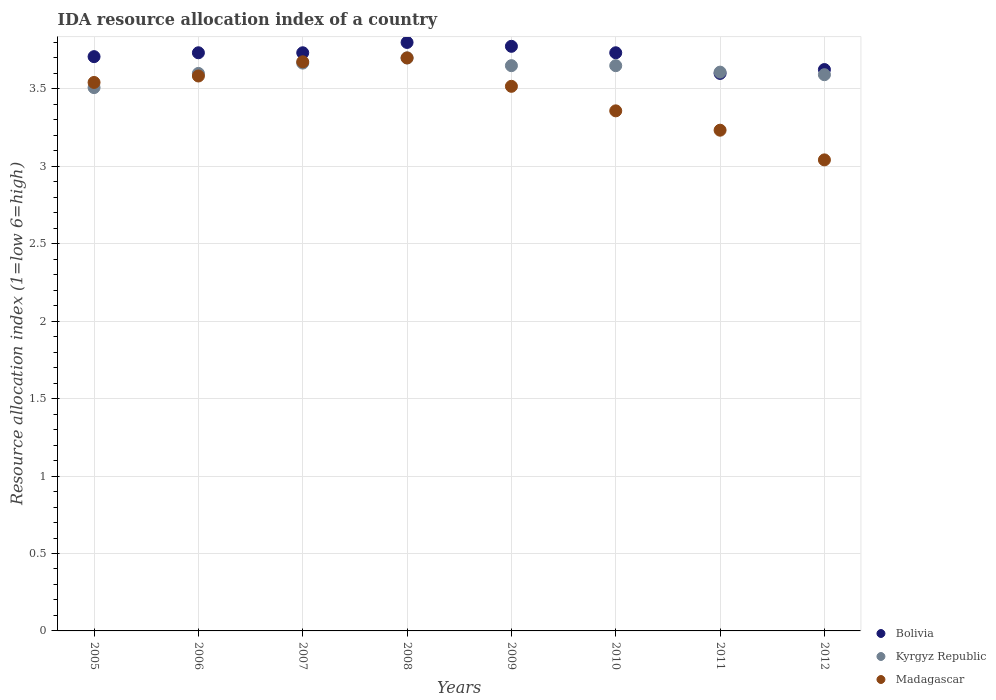How many different coloured dotlines are there?
Your response must be concise. 3. What is the IDA resource allocation index in Bolivia in 2010?
Your response must be concise. 3.73. Across all years, what is the maximum IDA resource allocation index in Kyrgyz Republic?
Offer a terse response. 3.7. Across all years, what is the minimum IDA resource allocation index in Kyrgyz Republic?
Your answer should be compact. 3.51. In which year was the IDA resource allocation index in Madagascar maximum?
Give a very brief answer. 2008. What is the total IDA resource allocation index in Bolivia in the graph?
Provide a short and direct response. 29.71. What is the difference between the IDA resource allocation index in Bolivia in 2005 and that in 2007?
Give a very brief answer. -0.02. What is the difference between the IDA resource allocation index in Madagascar in 2011 and the IDA resource allocation index in Bolivia in 2005?
Offer a very short reply. -0.47. What is the average IDA resource allocation index in Madagascar per year?
Keep it short and to the point. 3.46. In the year 2008, what is the difference between the IDA resource allocation index in Kyrgyz Republic and IDA resource allocation index in Bolivia?
Keep it short and to the point. -0.1. What is the ratio of the IDA resource allocation index in Kyrgyz Republic in 2005 to that in 2011?
Make the answer very short. 0.97. What is the difference between the highest and the second highest IDA resource allocation index in Kyrgyz Republic?
Provide a short and direct response. 0.03. What is the difference between the highest and the lowest IDA resource allocation index in Kyrgyz Republic?
Offer a terse response. 0.19. Is the sum of the IDA resource allocation index in Madagascar in 2005 and 2011 greater than the maximum IDA resource allocation index in Bolivia across all years?
Give a very brief answer. Yes. Does the IDA resource allocation index in Bolivia monotonically increase over the years?
Keep it short and to the point. No. Is the IDA resource allocation index in Madagascar strictly less than the IDA resource allocation index in Kyrgyz Republic over the years?
Your answer should be compact. No. Does the graph contain any zero values?
Your answer should be compact. No. What is the title of the graph?
Keep it short and to the point. IDA resource allocation index of a country. Does "Uruguay" appear as one of the legend labels in the graph?
Your response must be concise. No. What is the label or title of the Y-axis?
Your answer should be very brief. Resource allocation index (1=low 6=high). What is the Resource allocation index (1=low 6=high) in Bolivia in 2005?
Offer a terse response. 3.71. What is the Resource allocation index (1=low 6=high) in Kyrgyz Republic in 2005?
Your response must be concise. 3.51. What is the Resource allocation index (1=low 6=high) of Madagascar in 2005?
Ensure brevity in your answer.  3.54. What is the Resource allocation index (1=low 6=high) of Bolivia in 2006?
Make the answer very short. 3.73. What is the Resource allocation index (1=low 6=high) in Kyrgyz Republic in 2006?
Keep it short and to the point. 3.6. What is the Resource allocation index (1=low 6=high) of Madagascar in 2006?
Make the answer very short. 3.58. What is the Resource allocation index (1=low 6=high) of Bolivia in 2007?
Give a very brief answer. 3.73. What is the Resource allocation index (1=low 6=high) in Kyrgyz Republic in 2007?
Ensure brevity in your answer.  3.67. What is the Resource allocation index (1=low 6=high) of Madagascar in 2007?
Offer a terse response. 3.67. What is the Resource allocation index (1=low 6=high) in Bolivia in 2008?
Offer a very short reply. 3.8. What is the Resource allocation index (1=low 6=high) of Madagascar in 2008?
Offer a very short reply. 3.7. What is the Resource allocation index (1=low 6=high) in Bolivia in 2009?
Offer a very short reply. 3.77. What is the Resource allocation index (1=low 6=high) in Kyrgyz Republic in 2009?
Make the answer very short. 3.65. What is the Resource allocation index (1=low 6=high) in Madagascar in 2009?
Make the answer very short. 3.52. What is the Resource allocation index (1=low 6=high) in Bolivia in 2010?
Your answer should be very brief. 3.73. What is the Resource allocation index (1=low 6=high) of Kyrgyz Republic in 2010?
Your answer should be compact. 3.65. What is the Resource allocation index (1=low 6=high) in Madagascar in 2010?
Make the answer very short. 3.36. What is the Resource allocation index (1=low 6=high) in Kyrgyz Republic in 2011?
Offer a terse response. 3.61. What is the Resource allocation index (1=low 6=high) of Madagascar in 2011?
Provide a succinct answer. 3.23. What is the Resource allocation index (1=low 6=high) in Bolivia in 2012?
Your response must be concise. 3.62. What is the Resource allocation index (1=low 6=high) of Kyrgyz Republic in 2012?
Provide a succinct answer. 3.59. What is the Resource allocation index (1=low 6=high) of Madagascar in 2012?
Offer a terse response. 3.04. Across all years, what is the maximum Resource allocation index (1=low 6=high) in Bolivia?
Your answer should be very brief. 3.8. Across all years, what is the maximum Resource allocation index (1=low 6=high) in Kyrgyz Republic?
Make the answer very short. 3.7. Across all years, what is the minimum Resource allocation index (1=low 6=high) in Kyrgyz Republic?
Provide a succinct answer. 3.51. Across all years, what is the minimum Resource allocation index (1=low 6=high) of Madagascar?
Offer a very short reply. 3.04. What is the total Resource allocation index (1=low 6=high) in Bolivia in the graph?
Make the answer very short. 29.71. What is the total Resource allocation index (1=low 6=high) of Kyrgyz Republic in the graph?
Keep it short and to the point. 28.98. What is the total Resource allocation index (1=low 6=high) of Madagascar in the graph?
Make the answer very short. 27.65. What is the difference between the Resource allocation index (1=low 6=high) of Bolivia in 2005 and that in 2006?
Give a very brief answer. -0.03. What is the difference between the Resource allocation index (1=low 6=high) of Kyrgyz Republic in 2005 and that in 2006?
Provide a succinct answer. -0.09. What is the difference between the Resource allocation index (1=low 6=high) of Madagascar in 2005 and that in 2006?
Provide a short and direct response. -0.04. What is the difference between the Resource allocation index (1=low 6=high) of Bolivia in 2005 and that in 2007?
Give a very brief answer. -0.03. What is the difference between the Resource allocation index (1=low 6=high) in Kyrgyz Republic in 2005 and that in 2007?
Provide a short and direct response. -0.16. What is the difference between the Resource allocation index (1=low 6=high) in Madagascar in 2005 and that in 2007?
Offer a very short reply. -0.13. What is the difference between the Resource allocation index (1=low 6=high) in Bolivia in 2005 and that in 2008?
Make the answer very short. -0.09. What is the difference between the Resource allocation index (1=low 6=high) of Kyrgyz Republic in 2005 and that in 2008?
Your answer should be very brief. -0.19. What is the difference between the Resource allocation index (1=low 6=high) of Madagascar in 2005 and that in 2008?
Your response must be concise. -0.16. What is the difference between the Resource allocation index (1=low 6=high) of Bolivia in 2005 and that in 2009?
Provide a short and direct response. -0.07. What is the difference between the Resource allocation index (1=low 6=high) of Kyrgyz Republic in 2005 and that in 2009?
Your response must be concise. -0.14. What is the difference between the Resource allocation index (1=low 6=high) of Madagascar in 2005 and that in 2009?
Offer a terse response. 0.03. What is the difference between the Resource allocation index (1=low 6=high) in Bolivia in 2005 and that in 2010?
Offer a very short reply. -0.03. What is the difference between the Resource allocation index (1=low 6=high) of Kyrgyz Republic in 2005 and that in 2010?
Provide a succinct answer. -0.14. What is the difference between the Resource allocation index (1=low 6=high) in Madagascar in 2005 and that in 2010?
Give a very brief answer. 0.18. What is the difference between the Resource allocation index (1=low 6=high) in Bolivia in 2005 and that in 2011?
Provide a succinct answer. 0.11. What is the difference between the Resource allocation index (1=low 6=high) in Madagascar in 2005 and that in 2011?
Your answer should be very brief. 0.31. What is the difference between the Resource allocation index (1=low 6=high) of Bolivia in 2005 and that in 2012?
Offer a terse response. 0.08. What is the difference between the Resource allocation index (1=low 6=high) in Kyrgyz Republic in 2005 and that in 2012?
Your answer should be very brief. -0.08. What is the difference between the Resource allocation index (1=low 6=high) of Madagascar in 2005 and that in 2012?
Offer a terse response. 0.5. What is the difference between the Resource allocation index (1=low 6=high) in Kyrgyz Republic in 2006 and that in 2007?
Offer a very short reply. -0.07. What is the difference between the Resource allocation index (1=low 6=high) of Madagascar in 2006 and that in 2007?
Ensure brevity in your answer.  -0.09. What is the difference between the Resource allocation index (1=low 6=high) of Bolivia in 2006 and that in 2008?
Your response must be concise. -0.07. What is the difference between the Resource allocation index (1=low 6=high) in Kyrgyz Republic in 2006 and that in 2008?
Your response must be concise. -0.1. What is the difference between the Resource allocation index (1=low 6=high) in Madagascar in 2006 and that in 2008?
Provide a succinct answer. -0.12. What is the difference between the Resource allocation index (1=low 6=high) in Bolivia in 2006 and that in 2009?
Ensure brevity in your answer.  -0.04. What is the difference between the Resource allocation index (1=low 6=high) in Kyrgyz Republic in 2006 and that in 2009?
Offer a terse response. -0.05. What is the difference between the Resource allocation index (1=low 6=high) in Madagascar in 2006 and that in 2009?
Make the answer very short. 0.07. What is the difference between the Resource allocation index (1=low 6=high) of Madagascar in 2006 and that in 2010?
Offer a terse response. 0.23. What is the difference between the Resource allocation index (1=low 6=high) of Bolivia in 2006 and that in 2011?
Your answer should be compact. 0.13. What is the difference between the Resource allocation index (1=low 6=high) in Kyrgyz Republic in 2006 and that in 2011?
Ensure brevity in your answer.  -0.01. What is the difference between the Resource allocation index (1=low 6=high) in Bolivia in 2006 and that in 2012?
Keep it short and to the point. 0.11. What is the difference between the Resource allocation index (1=low 6=high) of Kyrgyz Republic in 2006 and that in 2012?
Make the answer very short. 0.01. What is the difference between the Resource allocation index (1=low 6=high) of Madagascar in 2006 and that in 2012?
Ensure brevity in your answer.  0.54. What is the difference between the Resource allocation index (1=low 6=high) of Bolivia in 2007 and that in 2008?
Make the answer very short. -0.07. What is the difference between the Resource allocation index (1=low 6=high) of Kyrgyz Republic in 2007 and that in 2008?
Your answer should be very brief. -0.03. What is the difference between the Resource allocation index (1=low 6=high) of Madagascar in 2007 and that in 2008?
Make the answer very short. -0.03. What is the difference between the Resource allocation index (1=low 6=high) in Bolivia in 2007 and that in 2009?
Your answer should be very brief. -0.04. What is the difference between the Resource allocation index (1=low 6=high) of Kyrgyz Republic in 2007 and that in 2009?
Make the answer very short. 0.02. What is the difference between the Resource allocation index (1=low 6=high) in Madagascar in 2007 and that in 2009?
Give a very brief answer. 0.16. What is the difference between the Resource allocation index (1=low 6=high) of Bolivia in 2007 and that in 2010?
Ensure brevity in your answer.  0. What is the difference between the Resource allocation index (1=low 6=high) in Kyrgyz Republic in 2007 and that in 2010?
Ensure brevity in your answer.  0.02. What is the difference between the Resource allocation index (1=low 6=high) in Madagascar in 2007 and that in 2010?
Your response must be concise. 0.32. What is the difference between the Resource allocation index (1=low 6=high) in Bolivia in 2007 and that in 2011?
Ensure brevity in your answer.  0.13. What is the difference between the Resource allocation index (1=low 6=high) in Kyrgyz Republic in 2007 and that in 2011?
Provide a short and direct response. 0.06. What is the difference between the Resource allocation index (1=low 6=high) in Madagascar in 2007 and that in 2011?
Your answer should be compact. 0.44. What is the difference between the Resource allocation index (1=low 6=high) in Bolivia in 2007 and that in 2012?
Make the answer very short. 0.11. What is the difference between the Resource allocation index (1=low 6=high) of Kyrgyz Republic in 2007 and that in 2012?
Provide a short and direct response. 0.07. What is the difference between the Resource allocation index (1=low 6=high) of Madagascar in 2007 and that in 2012?
Provide a short and direct response. 0.63. What is the difference between the Resource allocation index (1=low 6=high) in Bolivia in 2008 and that in 2009?
Make the answer very short. 0.03. What is the difference between the Resource allocation index (1=low 6=high) of Kyrgyz Republic in 2008 and that in 2009?
Ensure brevity in your answer.  0.05. What is the difference between the Resource allocation index (1=low 6=high) in Madagascar in 2008 and that in 2009?
Your response must be concise. 0.18. What is the difference between the Resource allocation index (1=low 6=high) of Bolivia in 2008 and that in 2010?
Offer a very short reply. 0.07. What is the difference between the Resource allocation index (1=low 6=high) in Kyrgyz Republic in 2008 and that in 2010?
Make the answer very short. 0.05. What is the difference between the Resource allocation index (1=low 6=high) of Madagascar in 2008 and that in 2010?
Offer a terse response. 0.34. What is the difference between the Resource allocation index (1=low 6=high) in Kyrgyz Republic in 2008 and that in 2011?
Make the answer very short. 0.09. What is the difference between the Resource allocation index (1=low 6=high) of Madagascar in 2008 and that in 2011?
Offer a terse response. 0.47. What is the difference between the Resource allocation index (1=low 6=high) of Bolivia in 2008 and that in 2012?
Offer a terse response. 0.17. What is the difference between the Resource allocation index (1=low 6=high) in Kyrgyz Republic in 2008 and that in 2012?
Offer a terse response. 0.11. What is the difference between the Resource allocation index (1=low 6=high) of Madagascar in 2008 and that in 2012?
Make the answer very short. 0.66. What is the difference between the Resource allocation index (1=low 6=high) in Bolivia in 2009 and that in 2010?
Make the answer very short. 0.04. What is the difference between the Resource allocation index (1=low 6=high) in Madagascar in 2009 and that in 2010?
Ensure brevity in your answer.  0.16. What is the difference between the Resource allocation index (1=low 6=high) in Bolivia in 2009 and that in 2011?
Your answer should be very brief. 0.17. What is the difference between the Resource allocation index (1=low 6=high) of Kyrgyz Republic in 2009 and that in 2011?
Give a very brief answer. 0.04. What is the difference between the Resource allocation index (1=low 6=high) in Madagascar in 2009 and that in 2011?
Make the answer very short. 0.28. What is the difference between the Resource allocation index (1=low 6=high) in Kyrgyz Republic in 2009 and that in 2012?
Your response must be concise. 0.06. What is the difference between the Resource allocation index (1=low 6=high) of Madagascar in 2009 and that in 2012?
Offer a very short reply. 0.47. What is the difference between the Resource allocation index (1=low 6=high) in Bolivia in 2010 and that in 2011?
Your response must be concise. 0.13. What is the difference between the Resource allocation index (1=low 6=high) in Kyrgyz Republic in 2010 and that in 2011?
Offer a terse response. 0.04. What is the difference between the Resource allocation index (1=low 6=high) in Bolivia in 2010 and that in 2012?
Make the answer very short. 0.11. What is the difference between the Resource allocation index (1=low 6=high) of Kyrgyz Republic in 2010 and that in 2012?
Ensure brevity in your answer.  0.06. What is the difference between the Resource allocation index (1=low 6=high) in Madagascar in 2010 and that in 2012?
Provide a short and direct response. 0.32. What is the difference between the Resource allocation index (1=low 6=high) in Bolivia in 2011 and that in 2012?
Offer a terse response. -0.03. What is the difference between the Resource allocation index (1=low 6=high) of Kyrgyz Republic in 2011 and that in 2012?
Make the answer very short. 0.02. What is the difference between the Resource allocation index (1=low 6=high) in Madagascar in 2011 and that in 2012?
Your response must be concise. 0.19. What is the difference between the Resource allocation index (1=low 6=high) of Bolivia in 2005 and the Resource allocation index (1=low 6=high) of Kyrgyz Republic in 2006?
Your response must be concise. 0.11. What is the difference between the Resource allocation index (1=low 6=high) in Kyrgyz Republic in 2005 and the Resource allocation index (1=low 6=high) in Madagascar in 2006?
Provide a succinct answer. -0.07. What is the difference between the Resource allocation index (1=low 6=high) of Bolivia in 2005 and the Resource allocation index (1=low 6=high) of Kyrgyz Republic in 2007?
Your response must be concise. 0.04. What is the difference between the Resource allocation index (1=low 6=high) in Bolivia in 2005 and the Resource allocation index (1=low 6=high) in Madagascar in 2007?
Provide a succinct answer. 0.03. What is the difference between the Resource allocation index (1=low 6=high) in Kyrgyz Republic in 2005 and the Resource allocation index (1=low 6=high) in Madagascar in 2007?
Your answer should be very brief. -0.17. What is the difference between the Resource allocation index (1=low 6=high) of Bolivia in 2005 and the Resource allocation index (1=low 6=high) of Kyrgyz Republic in 2008?
Your answer should be very brief. 0.01. What is the difference between the Resource allocation index (1=low 6=high) in Bolivia in 2005 and the Resource allocation index (1=low 6=high) in Madagascar in 2008?
Offer a terse response. 0.01. What is the difference between the Resource allocation index (1=low 6=high) of Kyrgyz Republic in 2005 and the Resource allocation index (1=low 6=high) of Madagascar in 2008?
Ensure brevity in your answer.  -0.19. What is the difference between the Resource allocation index (1=low 6=high) in Bolivia in 2005 and the Resource allocation index (1=low 6=high) in Kyrgyz Republic in 2009?
Give a very brief answer. 0.06. What is the difference between the Resource allocation index (1=low 6=high) of Bolivia in 2005 and the Resource allocation index (1=low 6=high) of Madagascar in 2009?
Provide a succinct answer. 0.19. What is the difference between the Resource allocation index (1=low 6=high) of Kyrgyz Republic in 2005 and the Resource allocation index (1=low 6=high) of Madagascar in 2009?
Provide a short and direct response. -0.01. What is the difference between the Resource allocation index (1=low 6=high) of Bolivia in 2005 and the Resource allocation index (1=low 6=high) of Kyrgyz Republic in 2010?
Offer a terse response. 0.06. What is the difference between the Resource allocation index (1=low 6=high) of Bolivia in 2005 and the Resource allocation index (1=low 6=high) of Madagascar in 2010?
Make the answer very short. 0.35. What is the difference between the Resource allocation index (1=low 6=high) in Kyrgyz Republic in 2005 and the Resource allocation index (1=low 6=high) in Madagascar in 2010?
Keep it short and to the point. 0.15. What is the difference between the Resource allocation index (1=low 6=high) of Bolivia in 2005 and the Resource allocation index (1=low 6=high) of Madagascar in 2011?
Your answer should be very brief. 0.47. What is the difference between the Resource allocation index (1=low 6=high) of Kyrgyz Republic in 2005 and the Resource allocation index (1=low 6=high) of Madagascar in 2011?
Your answer should be very brief. 0.28. What is the difference between the Resource allocation index (1=low 6=high) in Bolivia in 2005 and the Resource allocation index (1=low 6=high) in Kyrgyz Republic in 2012?
Offer a terse response. 0.12. What is the difference between the Resource allocation index (1=low 6=high) of Kyrgyz Republic in 2005 and the Resource allocation index (1=low 6=high) of Madagascar in 2012?
Keep it short and to the point. 0.47. What is the difference between the Resource allocation index (1=low 6=high) of Bolivia in 2006 and the Resource allocation index (1=low 6=high) of Kyrgyz Republic in 2007?
Offer a very short reply. 0.07. What is the difference between the Resource allocation index (1=low 6=high) in Bolivia in 2006 and the Resource allocation index (1=low 6=high) in Madagascar in 2007?
Keep it short and to the point. 0.06. What is the difference between the Resource allocation index (1=low 6=high) in Kyrgyz Republic in 2006 and the Resource allocation index (1=low 6=high) in Madagascar in 2007?
Your answer should be very brief. -0.07. What is the difference between the Resource allocation index (1=low 6=high) in Bolivia in 2006 and the Resource allocation index (1=low 6=high) in Kyrgyz Republic in 2008?
Your answer should be very brief. 0.03. What is the difference between the Resource allocation index (1=low 6=high) of Kyrgyz Republic in 2006 and the Resource allocation index (1=low 6=high) of Madagascar in 2008?
Your answer should be very brief. -0.1. What is the difference between the Resource allocation index (1=low 6=high) of Bolivia in 2006 and the Resource allocation index (1=low 6=high) of Kyrgyz Republic in 2009?
Offer a terse response. 0.08. What is the difference between the Resource allocation index (1=low 6=high) in Bolivia in 2006 and the Resource allocation index (1=low 6=high) in Madagascar in 2009?
Your answer should be very brief. 0.22. What is the difference between the Resource allocation index (1=low 6=high) of Kyrgyz Republic in 2006 and the Resource allocation index (1=low 6=high) of Madagascar in 2009?
Ensure brevity in your answer.  0.08. What is the difference between the Resource allocation index (1=low 6=high) of Bolivia in 2006 and the Resource allocation index (1=low 6=high) of Kyrgyz Republic in 2010?
Give a very brief answer. 0.08. What is the difference between the Resource allocation index (1=low 6=high) of Kyrgyz Republic in 2006 and the Resource allocation index (1=low 6=high) of Madagascar in 2010?
Give a very brief answer. 0.24. What is the difference between the Resource allocation index (1=low 6=high) of Bolivia in 2006 and the Resource allocation index (1=low 6=high) of Kyrgyz Republic in 2011?
Provide a succinct answer. 0.12. What is the difference between the Resource allocation index (1=low 6=high) in Kyrgyz Republic in 2006 and the Resource allocation index (1=low 6=high) in Madagascar in 2011?
Your answer should be very brief. 0.37. What is the difference between the Resource allocation index (1=low 6=high) of Bolivia in 2006 and the Resource allocation index (1=low 6=high) of Kyrgyz Republic in 2012?
Provide a succinct answer. 0.14. What is the difference between the Resource allocation index (1=low 6=high) of Bolivia in 2006 and the Resource allocation index (1=low 6=high) of Madagascar in 2012?
Give a very brief answer. 0.69. What is the difference between the Resource allocation index (1=low 6=high) in Kyrgyz Republic in 2006 and the Resource allocation index (1=low 6=high) in Madagascar in 2012?
Your answer should be very brief. 0.56. What is the difference between the Resource allocation index (1=low 6=high) of Bolivia in 2007 and the Resource allocation index (1=low 6=high) of Madagascar in 2008?
Your answer should be very brief. 0.03. What is the difference between the Resource allocation index (1=low 6=high) of Kyrgyz Republic in 2007 and the Resource allocation index (1=low 6=high) of Madagascar in 2008?
Give a very brief answer. -0.03. What is the difference between the Resource allocation index (1=low 6=high) of Bolivia in 2007 and the Resource allocation index (1=low 6=high) of Kyrgyz Republic in 2009?
Your response must be concise. 0.08. What is the difference between the Resource allocation index (1=low 6=high) in Bolivia in 2007 and the Resource allocation index (1=low 6=high) in Madagascar in 2009?
Your answer should be very brief. 0.22. What is the difference between the Resource allocation index (1=low 6=high) of Kyrgyz Republic in 2007 and the Resource allocation index (1=low 6=high) of Madagascar in 2009?
Keep it short and to the point. 0.15. What is the difference between the Resource allocation index (1=low 6=high) in Bolivia in 2007 and the Resource allocation index (1=low 6=high) in Kyrgyz Republic in 2010?
Your answer should be very brief. 0.08. What is the difference between the Resource allocation index (1=low 6=high) in Kyrgyz Republic in 2007 and the Resource allocation index (1=low 6=high) in Madagascar in 2010?
Offer a terse response. 0.31. What is the difference between the Resource allocation index (1=low 6=high) of Bolivia in 2007 and the Resource allocation index (1=low 6=high) of Kyrgyz Republic in 2011?
Provide a short and direct response. 0.12. What is the difference between the Resource allocation index (1=low 6=high) of Kyrgyz Republic in 2007 and the Resource allocation index (1=low 6=high) of Madagascar in 2011?
Your answer should be compact. 0.43. What is the difference between the Resource allocation index (1=low 6=high) in Bolivia in 2007 and the Resource allocation index (1=low 6=high) in Kyrgyz Republic in 2012?
Provide a succinct answer. 0.14. What is the difference between the Resource allocation index (1=low 6=high) of Bolivia in 2007 and the Resource allocation index (1=low 6=high) of Madagascar in 2012?
Offer a very short reply. 0.69. What is the difference between the Resource allocation index (1=low 6=high) in Bolivia in 2008 and the Resource allocation index (1=low 6=high) in Kyrgyz Republic in 2009?
Your answer should be very brief. 0.15. What is the difference between the Resource allocation index (1=low 6=high) in Bolivia in 2008 and the Resource allocation index (1=low 6=high) in Madagascar in 2009?
Give a very brief answer. 0.28. What is the difference between the Resource allocation index (1=low 6=high) of Kyrgyz Republic in 2008 and the Resource allocation index (1=low 6=high) of Madagascar in 2009?
Make the answer very short. 0.18. What is the difference between the Resource allocation index (1=low 6=high) of Bolivia in 2008 and the Resource allocation index (1=low 6=high) of Kyrgyz Republic in 2010?
Your response must be concise. 0.15. What is the difference between the Resource allocation index (1=low 6=high) of Bolivia in 2008 and the Resource allocation index (1=low 6=high) of Madagascar in 2010?
Ensure brevity in your answer.  0.44. What is the difference between the Resource allocation index (1=low 6=high) of Kyrgyz Republic in 2008 and the Resource allocation index (1=low 6=high) of Madagascar in 2010?
Keep it short and to the point. 0.34. What is the difference between the Resource allocation index (1=low 6=high) in Bolivia in 2008 and the Resource allocation index (1=low 6=high) in Kyrgyz Republic in 2011?
Offer a very short reply. 0.19. What is the difference between the Resource allocation index (1=low 6=high) of Bolivia in 2008 and the Resource allocation index (1=low 6=high) of Madagascar in 2011?
Your response must be concise. 0.57. What is the difference between the Resource allocation index (1=low 6=high) of Kyrgyz Republic in 2008 and the Resource allocation index (1=low 6=high) of Madagascar in 2011?
Keep it short and to the point. 0.47. What is the difference between the Resource allocation index (1=low 6=high) in Bolivia in 2008 and the Resource allocation index (1=low 6=high) in Kyrgyz Republic in 2012?
Make the answer very short. 0.21. What is the difference between the Resource allocation index (1=low 6=high) of Bolivia in 2008 and the Resource allocation index (1=low 6=high) of Madagascar in 2012?
Provide a succinct answer. 0.76. What is the difference between the Resource allocation index (1=low 6=high) in Kyrgyz Republic in 2008 and the Resource allocation index (1=low 6=high) in Madagascar in 2012?
Provide a short and direct response. 0.66. What is the difference between the Resource allocation index (1=low 6=high) in Bolivia in 2009 and the Resource allocation index (1=low 6=high) in Madagascar in 2010?
Keep it short and to the point. 0.42. What is the difference between the Resource allocation index (1=low 6=high) of Kyrgyz Republic in 2009 and the Resource allocation index (1=low 6=high) of Madagascar in 2010?
Keep it short and to the point. 0.29. What is the difference between the Resource allocation index (1=low 6=high) in Bolivia in 2009 and the Resource allocation index (1=low 6=high) in Kyrgyz Republic in 2011?
Make the answer very short. 0.17. What is the difference between the Resource allocation index (1=low 6=high) of Bolivia in 2009 and the Resource allocation index (1=low 6=high) of Madagascar in 2011?
Your response must be concise. 0.54. What is the difference between the Resource allocation index (1=low 6=high) in Kyrgyz Republic in 2009 and the Resource allocation index (1=low 6=high) in Madagascar in 2011?
Your answer should be very brief. 0.42. What is the difference between the Resource allocation index (1=low 6=high) of Bolivia in 2009 and the Resource allocation index (1=low 6=high) of Kyrgyz Republic in 2012?
Your answer should be compact. 0.18. What is the difference between the Resource allocation index (1=low 6=high) in Bolivia in 2009 and the Resource allocation index (1=low 6=high) in Madagascar in 2012?
Ensure brevity in your answer.  0.73. What is the difference between the Resource allocation index (1=low 6=high) in Kyrgyz Republic in 2009 and the Resource allocation index (1=low 6=high) in Madagascar in 2012?
Your answer should be compact. 0.61. What is the difference between the Resource allocation index (1=low 6=high) of Bolivia in 2010 and the Resource allocation index (1=low 6=high) of Kyrgyz Republic in 2011?
Keep it short and to the point. 0.12. What is the difference between the Resource allocation index (1=low 6=high) of Kyrgyz Republic in 2010 and the Resource allocation index (1=low 6=high) of Madagascar in 2011?
Give a very brief answer. 0.42. What is the difference between the Resource allocation index (1=low 6=high) of Bolivia in 2010 and the Resource allocation index (1=low 6=high) of Kyrgyz Republic in 2012?
Make the answer very short. 0.14. What is the difference between the Resource allocation index (1=low 6=high) of Bolivia in 2010 and the Resource allocation index (1=low 6=high) of Madagascar in 2012?
Your answer should be compact. 0.69. What is the difference between the Resource allocation index (1=low 6=high) in Kyrgyz Republic in 2010 and the Resource allocation index (1=low 6=high) in Madagascar in 2012?
Ensure brevity in your answer.  0.61. What is the difference between the Resource allocation index (1=low 6=high) of Bolivia in 2011 and the Resource allocation index (1=low 6=high) of Kyrgyz Republic in 2012?
Provide a succinct answer. 0.01. What is the difference between the Resource allocation index (1=low 6=high) of Bolivia in 2011 and the Resource allocation index (1=low 6=high) of Madagascar in 2012?
Ensure brevity in your answer.  0.56. What is the difference between the Resource allocation index (1=low 6=high) in Kyrgyz Republic in 2011 and the Resource allocation index (1=low 6=high) in Madagascar in 2012?
Provide a succinct answer. 0.57. What is the average Resource allocation index (1=low 6=high) of Bolivia per year?
Offer a terse response. 3.71. What is the average Resource allocation index (1=low 6=high) in Kyrgyz Republic per year?
Your answer should be compact. 3.62. What is the average Resource allocation index (1=low 6=high) of Madagascar per year?
Give a very brief answer. 3.46. In the year 2005, what is the difference between the Resource allocation index (1=low 6=high) of Bolivia and Resource allocation index (1=low 6=high) of Kyrgyz Republic?
Your answer should be very brief. 0.2. In the year 2005, what is the difference between the Resource allocation index (1=low 6=high) of Bolivia and Resource allocation index (1=low 6=high) of Madagascar?
Provide a succinct answer. 0.17. In the year 2005, what is the difference between the Resource allocation index (1=low 6=high) of Kyrgyz Republic and Resource allocation index (1=low 6=high) of Madagascar?
Ensure brevity in your answer.  -0.03. In the year 2006, what is the difference between the Resource allocation index (1=low 6=high) of Bolivia and Resource allocation index (1=low 6=high) of Kyrgyz Republic?
Ensure brevity in your answer.  0.13. In the year 2006, what is the difference between the Resource allocation index (1=low 6=high) of Bolivia and Resource allocation index (1=low 6=high) of Madagascar?
Offer a terse response. 0.15. In the year 2006, what is the difference between the Resource allocation index (1=low 6=high) of Kyrgyz Republic and Resource allocation index (1=low 6=high) of Madagascar?
Offer a terse response. 0.02. In the year 2007, what is the difference between the Resource allocation index (1=low 6=high) of Bolivia and Resource allocation index (1=low 6=high) of Kyrgyz Republic?
Offer a very short reply. 0.07. In the year 2007, what is the difference between the Resource allocation index (1=low 6=high) in Bolivia and Resource allocation index (1=low 6=high) in Madagascar?
Offer a very short reply. 0.06. In the year 2007, what is the difference between the Resource allocation index (1=low 6=high) in Kyrgyz Republic and Resource allocation index (1=low 6=high) in Madagascar?
Provide a succinct answer. -0.01. In the year 2008, what is the difference between the Resource allocation index (1=low 6=high) of Bolivia and Resource allocation index (1=low 6=high) of Kyrgyz Republic?
Your answer should be compact. 0.1. In the year 2008, what is the difference between the Resource allocation index (1=low 6=high) in Kyrgyz Republic and Resource allocation index (1=low 6=high) in Madagascar?
Give a very brief answer. 0. In the year 2009, what is the difference between the Resource allocation index (1=low 6=high) of Bolivia and Resource allocation index (1=low 6=high) of Madagascar?
Keep it short and to the point. 0.26. In the year 2009, what is the difference between the Resource allocation index (1=low 6=high) in Kyrgyz Republic and Resource allocation index (1=low 6=high) in Madagascar?
Your answer should be very brief. 0.13. In the year 2010, what is the difference between the Resource allocation index (1=low 6=high) of Bolivia and Resource allocation index (1=low 6=high) of Kyrgyz Republic?
Your response must be concise. 0.08. In the year 2010, what is the difference between the Resource allocation index (1=low 6=high) in Bolivia and Resource allocation index (1=low 6=high) in Madagascar?
Keep it short and to the point. 0.38. In the year 2010, what is the difference between the Resource allocation index (1=low 6=high) in Kyrgyz Republic and Resource allocation index (1=low 6=high) in Madagascar?
Make the answer very short. 0.29. In the year 2011, what is the difference between the Resource allocation index (1=low 6=high) of Bolivia and Resource allocation index (1=low 6=high) of Kyrgyz Republic?
Provide a succinct answer. -0.01. In the year 2011, what is the difference between the Resource allocation index (1=low 6=high) in Bolivia and Resource allocation index (1=low 6=high) in Madagascar?
Your answer should be compact. 0.37. In the year 2011, what is the difference between the Resource allocation index (1=low 6=high) in Kyrgyz Republic and Resource allocation index (1=low 6=high) in Madagascar?
Your answer should be very brief. 0.38. In the year 2012, what is the difference between the Resource allocation index (1=low 6=high) of Bolivia and Resource allocation index (1=low 6=high) of Madagascar?
Keep it short and to the point. 0.58. In the year 2012, what is the difference between the Resource allocation index (1=low 6=high) in Kyrgyz Republic and Resource allocation index (1=low 6=high) in Madagascar?
Give a very brief answer. 0.55. What is the ratio of the Resource allocation index (1=low 6=high) in Bolivia in 2005 to that in 2006?
Keep it short and to the point. 0.99. What is the ratio of the Resource allocation index (1=low 6=high) of Kyrgyz Republic in 2005 to that in 2006?
Provide a succinct answer. 0.97. What is the ratio of the Resource allocation index (1=low 6=high) of Madagascar in 2005 to that in 2006?
Ensure brevity in your answer.  0.99. What is the ratio of the Resource allocation index (1=low 6=high) of Bolivia in 2005 to that in 2007?
Offer a very short reply. 0.99. What is the ratio of the Resource allocation index (1=low 6=high) of Kyrgyz Republic in 2005 to that in 2007?
Make the answer very short. 0.96. What is the ratio of the Resource allocation index (1=low 6=high) in Madagascar in 2005 to that in 2007?
Ensure brevity in your answer.  0.96. What is the ratio of the Resource allocation index (1=low 6=high) of Bolivia in 2005 to that in 2008?
Provide a short and direct response. 0.98. What is the ratio of the Resource allocation index (1=low 6=high) in Kyrgyz Republic in 2005 to that in 2008?
Keep it short and to the point. 0.95. What is the ratio of the Resource allocation index (1=low 6=high) of Madagascar in 2005 to that in 2008?
Your response must be concise. 0.96. What is the ratio of the Resource allocation index (1=low 6=high) in Bolivia in 2005 to that in 2009?
Your answer should be very brief. 0.98. What is the ratio of the Resource allocation index (1=low 6=high) of Kyrgyz Republic in 2005 to that in 2009?
Keep it short and to the point. 0.96. What is the ratio of the Resource allocation index (1=low 6=high) of Madagascar in 2005 to that in 2009?
Your answer should be very brief. 1.01. What is the ratio of the Resource allocation index (1=low 6=high) in Bolivia in 2005 to that in 2010?
Keep it short and to the point. 0.99. What is the ratio of the Resource allocation index (1=low 6=high) of Kyrgyz Republic in 2005 to that in 2010?
Your answer should be compact. 0.96. What is the ratio of the Resource allocation index (1=low 6=high) in Madagascar in 2005 to that in 2010?
Keep it short and to the point. 1.05. What is the ratio of the Resource allocation index (1=low 6=high) in Bolivia in 2005 to that in 2011?
Provide a short and direct response. 1.03. What is the ratio of the Resource allocation index (1=low 6=high) of Kyrgyz Republic in 2005 to that in 2011?
Your answer should be compact. 0.97. What is the ratio of the Resource allocation index (1=low 6=high) of Madagascar in 2005 to that in 2011?
Provide a succinct answer. 1.1. What is the ratio of the Resource allocation index (1=low 6=high) in Bolivia in 2005 to that in 2012?
Provide a succinct answer. 1.02. What is the ratio of the Resource allocation index (1=low 6=high) in Kyrgyz Republic in 2005 to that in 2012?
Ensure brevity in your answer.  0.98. What is the ratio of the Resource allocation index (1=low 6=high) in Madagascar in 2005 to that in 2012?
Your response must be concise. 1.16. What is the ratio of the Resource allocation index (1=low 6=high) of Kyrgyz Republic in 2006 to that in 2007?
Your answer should be very brief. 0.98. What is the ratio of the Resource allocation index (1=low 6=high) in Madagascar in 2006 to that in 2007?
Provide a short and direct response. 0.98. What is the ratio of the Resource allocation index (1=low 6=high) in Bolivia in 2006 to that in 2008?
Give a very brief answer. 0.98. What is the ratio of the Resource allocation index (1=low 6=high) of Kyrgyz Republic in 2006 to that in 2008?
Offer a very short reply. 0.97. What is the ratio of the Resource allocation index (1=low 6=high) in Madagascar in 2006 to that in 2008?
Offer a terse response. 0.97. What is the ratio of the Resource allocation index (1=low 6=high) of Kyrgyz Republic in 2006 to that in 2009?
Give a very brief answer. 0.99. What is the ratio of the Resource allocation index (1=low 6=high) in Madagascar in 2006 to that in 2009?
Your response must be concise. 1.02. What is the ratio of the Resource allocation index (1=low 6=high) in Kyrgyz Republic in 2006 to that in 2010?
Offer a very short reply. 0.99. What is the ratio of the Resource allocation index (1=low 6=high) in Madagascar in 2006 to that in 2010?
Ensure brevity in your answer.  1.07. What is the ratio of the Resource allocation index (1=low 6=high) in Bolivia in 2006 to that in 2011?
Your response must be concise. 1.04. What is the ratio of the Resource allocation index (1=low 6=high) of Madagascar in 2006 to that in 2011?
Provide a succinct answer. 1.11. What is the ratio of the Resource allocation index (1=low 6=high) of Bolivia in 2006 to that in 2012?
Your answer should be very brief. 1.03. What is the ratio of the Resource allocation index (1=low 6=high) in Kyrgyz Republic in 2006 to that in 2012?
Your answer should be compact. 1. What is the ratio of the Resource allocation index (1=low 6=high) of Madagascar in 2006 to that in 2012?
Provide a succinct answer. 1.18. What is the ratio of the Resource allocation index (1=low 6=high) of Bolivia in 2007 to that in 2008?
Offer a very short reply. 0.98. What is the ratio of the Resource allocation index (1=low 6=high) of Kyrgyz Republic in 2007 to that in 2008?
Keep it short and to the point. 0.99. What is the ratio of the Resource allocation index (1=low 6=high) in Madagascar in 2007 to that in 2008?
Keep it short and to the point. 0.99. What is the ratio of the Resource allocation index (1=low 6=high) of Bolivia in 2007 to that in 2009?
Ensure brevity in your answer.  0.99. What is the ratio of the Resource allocation index (1=low 6=high) of Kyrgyz Republic in 2007 to that in 2009?
Offer a terse response. 1. What is the ratio of the Resource allocation index (1=low 6=high) of Madagascar in 2007 to that in 2009?
Offer a very short reply. 1.04. What is the ratio of the Resource allocation index (1=low 6=high) in Bolivia in 2007 to that in 2010?
Offer a terse response. 1. What is the ratio of the Resource allocation index (1=low 6=high) in Madagascar in 2007 to that in 2010?
Give a very brief answer. 1.09. What is the ratio of the Resource allocation index (1=low 6=high) of Bolivia in 2007 to that in 2011?
Give a very brief answer. 1.04. What is the ratio of the Resource allocation index (1=low 6=high) in Kyrgyz Republic in 2007 to that in 2011?
Offer a very short reply. 1.02. What is the ratio of the Resource allocation index (1=low 6=high) of Madagascar in 2007 to that in 2011?
Your response must be concise. 1.14. What is the ratio of the Resource allocation index (1=low 6=high) of Bolivia in 2007 to that in 2012?
Your answer should be compact. 1.03. What is the ratio of the Resource allocation index (1=low 6=high) of Kyrgyz Republic in 2007 to that in 2012?
Your response must be concise. 1.02. What is the ratio of the Resource allocation index (1=low 6=high) of Madagascar in 2007 to that in 2012?
Ensure brevity in your answer.  1.21. What is the ratio of the Resource allocation index (1=low 6=high) in Bolivia in 2008 to that in 2009?
Give a very brief answer. 1.01. What is the ratio of the Resource allocation index (1=low 6=high) of Kyrgyz Republic in 2008 to that in 2009?
Offer a terse response. 1.01. What is the ratio of the Resource allocation index (1=low 6=high) in Madagascar in 2008 to that in 2009?
Give a very brief answer. 1.05. What is the ratio of the Resource allocation index (1=low 6=high) of Bolivia in 2008 to that in 2010?
Offer a very short reply. 1.02. What is the ratio of the Resource allocation index (1=low 6=high) in Kyrgyz Republic in 2008 to that in 2010?
Your answer should be very brief. 1.01. What is the ratio of the Resource allocation index (1=low 6=high) of Madagascar in 2008 to that in 2010?
Your answer should be very brief. 1.1. What is the ratio of the Resource allocation index (1=low 6=high) in Bolivia in 2008 to that in 2011?
Give a very brief answer. 1.06. What is the ratio of the Resource allocation index (1=low 6=high) of Kyrgyz Republic in 2008 to that in 2011?
Ensure brevity in your answer.  1.03. What is the ratio of the Resource allocation index (1=low 6=high) of Madagascar in 2008 to that in 2011?
Your answer should be compact. 1.14. What is the ratio of the Resource allocation index (1=low 6=high) of Bolivia in 2008 to that in 2012?
Give a very brief answer. 1.05. What is the ratio of the Resource allocation index (1=low 6=high) in Kyrgyz Republic in 2008 to that in 2012?
Offer a terse response. 1.03. What is the ratio of the Resource allocation index (1=low 6=high) of Madagascar in 2008 to that in 2012?
Ensure brevity in your answer.  1.22. What is the ratio of the Resource allocation index (1=low 6=high) of Bolivia in 2009 to that in 2010?
Your answer should be compact. 1.01. What is the ratio of the Resource allocation index (1=low 6=high) in Madagascar in 2009 to that in 2010?
Provide a short and direct response. 1.05. What is the ratio of the Resource allocation index (1=low 6=high) of Bolivia in 2009 to that in 2011?
Your answer should be compact. 1.05. What is the ratio of the Resource allocation index (1=low 6=high) of Kyrgyz Republic in 2009 to that in 2011?
Make the answer very short. 1.01. What is the ratio of the Resource allocation index (1=low 6=high) of Madagascar in 2009 to that in 2011?
Offer a very short reply. 1.09. What is the ratio of the Resource allocation index (1=low 6=high) of Bolivia in 2009 to that in 2012?
Offer a terse response. 1.04. What is the ratio of the Resource allocation index (1=low 6=high) of Kyrgyz Republic in 2009 to that in 2012?
Your response must be concise. 1.02. What is the ratio of the Resource allocation index (1=low 6=high) of Madagascar in 2009 to that in 2012?
Your response must be concise. 1.16. What is the ratio of the Resource allocation index (1=low 6=high) of Bolivia in 2010 to that in 2011?
Your response must be concise. 1.04. What is the ratio of the Resource allocation index (1=low 6=high) of Kyrgyz Republic in 2010 to that in 2011?
Your answer should be very brief. 1.01. What is the ratio of the Resource allocation index (1=low 6=high) of Madagascar in 2010 to that in 2011?
Your answer should be very brief. 1.04. What is the ratio of the Resource allocation index (1=low 6=high) of Bolivia in 2010 to that in 2012?
Offer a very short reply. 1.03. What is the ratio of the Resource allocation index (1=low 6=high) of Kyrgyz Republic in 2010 to that in 2012?
Your answer should be compact. 1.02. What is the ratio of the Resource allocation index (1=low 6=high) of Madagascar in 2010 to that in 2012?
Keep it short and to the point. 1.1. What is the ratio of the Resource allocation index (1=low 6=high) in Bolivia in 2011 to that in 2012?
Offer a terse response. 0.99. What is the ratio of the Resource allocation index (1=low 6=high) of Madagascar in 2011 to that in 2012?
Offer a very short reply. 1.06. What is the difference between the highest and the second highest Resource allocation index (1=low 6=high) of Bolivia?
Keep it short and to the point. 0.03. What is the difference between the highest and the second highest Resource allocation index (1=low 6=high) of Kyrgyz Republic?
Keep it short and to the point. 0.03. What is the difference between the highest and the second highest Resource allocation index (1=low 6=high) in Madagascar?
Provide a short and direct response. 0.03. What is the difference between the highest and the lowest Resource allocation index (1=low 6=high) in Bolivia?
Provide a short and direct response. 0.2. What is the difference between the highest and the lowest Resource allocation index (1=low 6=high) of Kyrgyz Republic?
Offer a very short reply. 0.19. What is the difference between the highest and the lowest Resource allocation index (1=low 6=high) in Madagascar?
Your response must be concise. 0.66. 